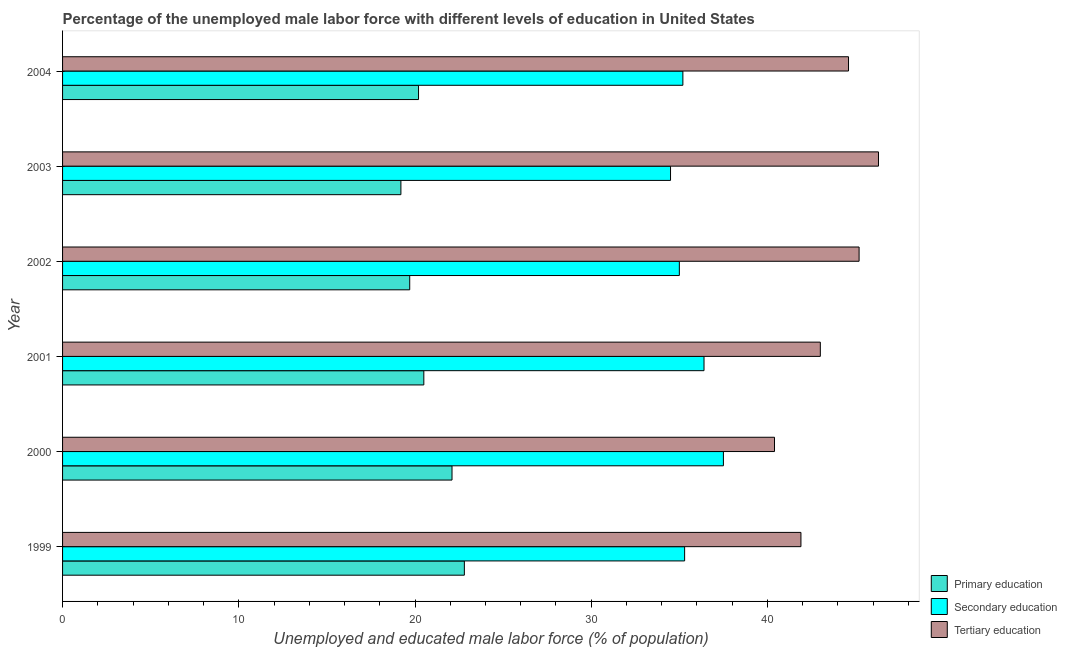How many different coloured bars are there?
Keep it short and to the point. 3. How many bars are there on the 4th tick from the top?
Give a very brief answer. 3. What is the label of the 4th group of bars from the top?
Your response must be concise. 2001. In how many cases, is the number of bars for a given year not equal to the number of legend labels?
Give a very brief answer. 0. What is the percentage of male labor force who received tertiary education in 1999?
Offer a very short reply. 41.9. Across all years, what is the maximum percentage of male labor force who received secondary education?
Make the answer very short. 37.5. Across all years, what is the minimum percentage of male labor force who received tertiary education?
Your answer should be compact. 40.4. In which year was the percentage of male labor force who received secondary education maximum?
Ensure brevity in your answer.  2000. What is the total percentage of male labor force who received primary education in the graph?
Give a very brief answer. 124.5. What is the difference between the percentage of male labor force who received tertiary education in 1999 and that in 2000?
Your answer should be compact. 1.5. What is the difference between the percentage of male labor force who received secondary education in 1999 and the percentage of male labor force who received tertiary education in 2004?
Offer a very short reply. -9.3. What is the average percentage of male labor force who received secondary education per year?
Provide a succinct answer. 35.65. In how many years, is the percentage of male labor force who received primary education greater than 18 %?
Your answer should be very brief. 6. What is the ratio of the percentage of male labor force who received secondary education in 1999 to that in 2000?
Your answer should be very brief. 0.94. Is the percentage of male labor force who received secondary education in 1999 less than that in 2000?
Your response must be concise. Yes. What is the difference between the highest and the second highest percentage of male labor force who received tertiary education?
Make the answer very short. 1.1. What is the difference between the highest and the lowest percentage of male labor force who received primary education?
Offer a terse response. 3.6. In how many years, is the percentage of male labor force who received secondary education greater than the average percentage of male labor force who received secondary education taken over all years?
Keep it short and to the point. 2. What does the 2nd bar from the bottom in 2001 represents?
Your answer should be very brief. Secondary education. How many bars are there?
Provide a succinct answer. 18. Are all the bars in the graph horizontal?
Give a very brief answer. Yes. How many years are there in the graph?
Make the answer very short. 6. What is the difference between two consecutive major ticks on the X-axis?
Your answer should be compact. 10. Does the graph contain any zero values?
Offer a very short reply. No. Does the graph contain grids?
Provide a succinct answer. No. What is the title of the graph?
Provide a succinct answer. Percentage of the unemployed male labor force with different levels of education in United States. Does "Non-communicable diseases" appear as one of the legend labels in the graph?
Provide a succinct answer. No. What is the label or title of the X-axis?
Your answer should be compact. Unemployed and educated male labor force (% of population). What is the label or title of the Y-axis?
Keep it short and to the point. Year. What is the Unemployed and educated male labor force (% of population) in Primary education in 1999?
Offer a very short reply. 22.8. What is the Unemployed and educated male labor force (% of population) of Secondary education in 1999?
Keep it short and to the point. 35.3. What is the Unemployed and educated male labor force (% of population) in Tertiary education in 1999?
Your answer should be very brief. 41.9. What is the Unemployed and educated male labor force (% of population) in Primary education in 2000?
Your response must be concise. 22.1. What is the Unemployed and educated male labor force (% of population) of Secondary education in 2000?
Your answer should be compact. 37.5. What is the Unemployed and educated male labor force (% of population) in Tertiary education in 2000?
Give a very brief answer. 40.4. What is the Unemployed and educated male labor force (% of population) in Secondary education in 2001?
Your answer should be compact. 36.4. What is the Unemployed and educated male labor force (% of population) in Primary education in 2002?
Your response must be concise. 19.7. What is the Unemployed and educated male labor force (% of population) of Secondary education in 2002?
Make the answer very short. 35. What is the Unemployed and educated male labor force (% of population) in Tertiary education in 2002?
Give a very brief answer. 45.2. What is the Unemployed and educated male labor force (% of population) of Primary education in 2003?
Your answer should be very brief. 19.2. What is the Unemployed and educated male labor force (% of population) in Secondary education in 2003?
Keep it short and to the point. 34.5. What is the Unemployed and educated male labor force (% of population) in Tertiary education in 2003?
Keep it short and to the point. 46.3. What is the Unemployed and educated male labor force (% of population) of Primary education in 2004?
Provide a succinct answer. 20.2. What is the Unemployed and educated male labor force (% of population) of Secondary education in 2004?
Your response must be concise. 35.2. What is the Unemployed and educated male labor force (% of population) in Tertiary education in 2004?
Offer a very short reply. 44.6. Across all years, what is the maximum Unemployed and educated male labor force (% of population) in Primary education?
Ensure brevity in your answer.  22.8. Across all years, what is the maximum Unemployed and educated male labor force (% of population) in Secondary education?
Ensure brevity in your answer.  37.5. Across all years, what is the maximum Unemployed and educated male labor force (% of population) of Tertiary education?
Your answer should be very brief. 46.3. Across all years, what is the minimum Unemployed and educated male labor force (% of population) in Primary education?
Provide a short and direct response. 19.2. Across all years, what is the minimum Unemployed and educated male labor force (% of population) in Secondary education?
Ensure brevity in your answer.  34.5. Across all years, what is the minimum Unemployed and educated male labor force (% of population) in Tertiary education?
Offer a terse response. 40.4. What is the total Unemployed and educated male labor force (% of population) of Primary education in the graph?
Provide a short and direct response. 124.5. What is the total Unemployed and educated male labor force (% of population) of Secondary education in the graph?
Ensure brevity in your answer.  213.9. What is the total Unemployed and educated male labor force (% of population) in Tertiary education in the graph?
Offer a terse response. 261.4. What is the difference between the Unemployed and educated male labor force (% of population) in Secondary education in 1999 and that in 2000?
Your answer should be compact. -2.2. What is the difference between the Unemployed and educated male labor force (% of population) in Tertiary education in 1999 and that in 2000?
Keep it short and to the point. 1.5. What is the difference between the Unemployed and educated male labor force (% of population) of Primary education in 1999 and that in 2001?
Your answer should be compact. 2.3. What is the difference between the Unemployed and educated male labor force (% of population) of Secondary education in 1999 and that in 2001?
Offer a very short reply. -1.1. What is the difference between the Unemployed and educated male labor force (% of population) of Secondary education in 1999 and that in 2002?
Your answer should be compact. 0.3. What is the difference between the Unemployed and educated male labor force (% of population) of Secondary education in 1999 and that in 2003?
Make the answer very short. 0.8. What is the difference between the Unemployed and educated male labor force (% of population) in Primary education in 1999 and that in 2004?
Make the answer very short. 2.6. What is the difference between the Unemployed and educated male labor force (% of population) of Secondary education in 1999 and that in 2004?
Give a very brief answer. 0.1. What is the difference between the Unemployed and educated male labor force (% of population) of Secondary education in 2000 and that in 2001?
Offer a very short reply. 1.1. What is the difference between the Unemployed and educated male labor force (% of population) of Secondary education in 2000 and that in 2002?
Offer a very short reply. 2.5. What is the difference between the Unemployed and educated male labor force (% of population) of Tertiary education in 2000 and that in 2002?
Provide a succinct answer. -4.8. What is the difference between the Unemployed and educated male labor force (% of population) in Primary education in 2000 and that in 2003?
Keep it short and to the point. 2.9. What is the difference between the Unemployed and educated male labor force (% of population) in Secondary education in 2000 and that in 2003?
Your response must be concise. 3. What is the difference between the Unemployed and educated male labor force (% of population) of Primary education in 2000 and that in 2004?
Your answer should be compact. 1.9. What is the difference between the Unemployed and educated male labor force (% of population) in Tertiary education in 2000 and that in 2004?
Keep it short and to the point. -4.2. What is the difference between the Unemployed and educated male labor force (% of population) in Primary education in 2001 and that in 2002?
Provide a succinct answer. 0.8. What is the difference between the Unemployed and educated male labor force (% of population) of Tertiary education in 2001 and that in 2002?
Provide a short and direct response. -2.2. What is the difference between the Unemployed and educated male labor force (% of population) in Secondary education in 2001 and that in 2003?
Ensure brevity in your answer.  1.9. What is the difference between the Unemployed and educated male labor force (% of population) of Tertiary education in 2001 and that in 2003?
Provide a short and direct response. -3.3. What is the difference between the Unemployed and educated male labor force (% of population) of Primary education in 2001 and that in 2004?
Your answer should be very brief. 0.3. What is the difference between the Unemployed and educated male labor force (% of population) in Secondary education in 2001 and that in 2004?
Ensure brevity in your answer.  1.2. What is the difference between the Unemployed and educated male labor force (% of population) of Primary education in 2002 and that in 2003?
Make the answer very short. 0.5. What is the difference between the Unemployed and educated male labor force (% of population) in Tertiary education in 2002 and that in 2003?
Your response must be concise. -1.1. What is the difference between the Unemployed and educated male labor force (% of population) of Secondary education in 2002 and that in 2004?
Ensure brevity in your answer.  -0.2. What is the difference between the Unemployed and educated male labor force (% of population) of Tertiary education in 2002 and that in 2004?
Your response must be concise. 0.6. What is the difference between the Unemployed and educated male labor force (% of population) of Primary education in 2003 and that in 2004?
Offer a terse response. -1. What is the difference between the Unemployed and educated male labor force (% of population) of Secondary education in 2003 and that in 2004?
Your response must be concise. -0.7. What is the difference between the Unemployed and educated male labor force (% of population) in Tertiary education in 2003 and that in 2004?
Give a very brief answer. 1.7. What is the difference between the Unemployed and educated male labor force (% of population) in Primary education in 1999 and the Unemployed and educated male labor force (% of population) in Secondary education in 2000?
Your response must be concise. -14.7. What is the difference between the Unemployed and educated male labor force (% of population) in Primary education in 1999 and the Unemployed and educated male labor force (% of population) in Tertiary education in 2000?
Your answer should be compact. -17.6. What is the difference between the Unemployed and educated male labor force (% of population) in Primary education in 1999 and the Unemployed and educated male labor force (% of population) in Secondary education in 2001?
Your answer should be compact. -13.6. What is the difference between the Unemployed and educated male labor force (% of population) in Primary education in 1999 and the Unemployed and educated male labor force (% of population) in Tertiary education in 2001?
Your answer should be compact. -20.2. What is the difference between the Unemployed and educated male labor force (% of population) in Primary education in 1999 and the Unemployed and educated male labor force (% of population) in Secondary education in 2002?
Provide a succinct answer. -12.2. What is the difference between the Unemployed and educated male labor force (% of population) of Primary education in 1999 and the Unemployed and educated male labor force (% of population) of Tertiary education in 2002?
Your answer should be very brief. -22.4. What is the difference between the Unemployed and educated male labor force (% of population) in Secondary education in 1999 and the Unemployed and educated male labor force (% of population) in Tertiary education in 2002?
Your answer should be very brief. -9.9. What is the difference between the Unemployed and educated male labor force (% of population) in Primary education in 1999 and the Unemployed and educated male labor force (% of population) in Tertiary education in 2003?
Offer a terse response. -23.5. What is the difference between the Unemployed and educated male labor force (% of population) in Primary education in 1999 and the Unemployed and educated male labor force (% of population) in Secondary education in 2004?
Make the answer very short. -12.4. What is the difference between the Unemployed and educated male labor force (% of population) in Primary education in 1999 and the Unemployed and educated male labor force (% of population) in Tertiary education in 2004?
Make the answer very short. -21.8. What is the difference between the Unemployed and educated male labor force (% of population) in Primary education in 2000 and the Unemployed and educated male labor force (% of population) in Secondary education in 2001?
Provide a succinct answer. -14.3. What is the difference between the Unemployed and educated male labor force (% of population) in Primary education in 2000 and the Unemployed and educated male labor force (% of population) in Tertiary education in 2001?
Your answer should be compact. -20.9. What is the difference between the Unemployed and educated male labor force (% of population) of Primary education in 2000 and the Unemployed and educated male labor force (% of population) of Tertiary education in 2002?
Provide a short and direct response. -23.1. What is the difference between the Unemployed and educated male labor force (% of population) of Secondary education in 2000 and the Unemployed and educated male labor force (% of population) of Tertiary education in 2002?
Give a very brief answer. -7.7. What is the difference between the Unemployed and educated male labor force (% of population) in Primary education in 2000 and the Unemployed and educated male labor force (% of population) in Tertiary education in 2003?
Your answer should be compact. -24.2. What is the difference between the Unemployed and educated male labor force (% of population) of Secondary education in 2000 and the Unemployed and educated male labor force (% of population) of Tertiary education in 2003?
Your answer should be very brief. -8.8. What is the difference between the Unemployed and educated male labor force (% of population) of Primary education in 2000 and the Unemployed and educated male labor force (% of population) of Secondary education in 2004?
Make the answer very short. -13.1. What is the difference between the Unemployed and educated male labor force (% of population) of Primary education in 2000 and the Unemployed and educated male labor force (% of population) of Tertiary education in 2004?
Make the answer very short. -22.5. What is the difference between the Unemployed and educated male labor force (% of population) of Primary education in 2001 and the Unemployed and educated male labor force (% of population) of Tertiary education in 2002?
Keep it short and to the point. -24.7. What is the difference between the Unemployed and educated male labor force (% of population) in Secondary education in 2001 and the Unemployed and educated male labor force (% of population) in Tertiary education in 2002?
Make the answer very short. -8.8. What is the difference between the Unemployed and educated male labor force (% of population) of Primary education in 2001 and the Unemployed and educated male labor force (% of population) of Secondary education in 2003?
Give a very brief answer. -14. What is the difference between the Unemployed and educated male labor force (% of population) of Primary education in 2001 and the Unemployed and educated male labor force (% of population) of Tertiary education in 2003?
Keep it short and to the point. -25.8. What is the difference between the Unemployed and educated male labor force (% of population) of Secondary education in 2001 and the Unemployed and educated male labor force (% of population) of Tertiary education in 2003?
Provide a short and direct response. -9.9. What is the difference between the Unemployed and educated male labor force (% of population) of Primary education in 2001 and the Unemployed and educated male labor force (% of population) of Secondary education in 2004?
Make the answer very short. -14.7. What is the difference between the Unemployed and educated male labor force (% of population) in Primary education in 2001 and the Unemployed and educated male labor force (% of population) in Tertiary education in 2004?
Offer a very short reply. -24.1. What is the difference between the Unemployed and educated male labor force (% of population) of Secondary education in 2001 and the Unemployed and educated male labor force (% of population) of Tertiary education in 2004?
Provide a succinct answer. -8.2. What is the difference between the Unemployed and educated male labor force (% of population) of Primary education in 2002 and the Unemployed and educated male labor force (% of population) of Secondary education in 2003?
Provide a short and direct response. -14.8. What is the difference between the Unemployed and educated male labor force (% of population) of Primary education in 2002 and the Unemployed and educated male labor force (% of population) of Tertiary education in 2003?
Make the answer very short. -26.6. What is the difference between the Unemployed and educated male labor force (% of population) of Primary education in 2002 and the Unemployed and educated male labor force (% of population) of Secondary education in 2004?
Your response must be concise. -15.5. What is the difference between the Unemployed and educated male labor force (% of population) of Primary education in 2002 and the Unemployed and educated male labor force (% of population) of Tertiary education in 2004?
Ensure brevity in your answer.  -24.9. What is the difference between the Unemployed and educated male labor force (% of population) of Primary education in 2003 and the Unemployed and educated male labor force (% of population) of Tertiary education in 2004?
Your answer should be compact. -25.4. What is the difference between the Unemployed and educated male labor force (% of population) of Secondary education in 2003 and the Unemployed and educated male labor force (% of population) of Tertiary education in 2004?
Your answer should be very brief. -10.1. What is the average Unemployed and educated male labor force (% of population) in Primary education per year?
Your response must be concise. 20.75. What is the average Unemployed and educated male labor force (% of population) of Secondary education per year?
Offer a terse response. 35.65. What is the average Unemployed and educated male labor force (% of population) of Tertiary education per year?
Offer a terse response. 43.57. In the year 1999, what is the difference between the Unemployed and educated male labor force (% of population) in Primary education and Unemployed and educated male labor force (% of population) in Secondary education?
Keep it short and to the point. -12.5. In the year 1999, what is the difference between the Unemployed and educated male labor force (% of population) of Primary education and Unemployed and educated male labor force (% of population) of Tertiary education?
Give a very brief answer. -19.1. In the year 1999, what is the difference between the Unemployed and educated male labor force (% of population) of Secondary education and Unemployed and educated male labor force (% of population) of Tertiary education?
Your answer should be compact. -6.6. In the year 2000, what is the difference between the Unemployed and educated male labor force (% of population) in Primary education and Unemployed and educated male labor force (% of population) in Secondary education?
Keep it short and to the point. -15.4. In the year 2000, what is the difference between the Unemployed and educated male labor force (% of population) of Primary education and Unemployed and educated male labor force (% of population) of Tertiary education?
Offer a very short reply. -18.3. In the year 2000, what is the difference between the Unemployed and educated male labor force (% of population) of Secondary education and Unemployed and educated male labor force (% of population) of Tertiary education?
Keep it short and to the point. -2.9. In the year 2001, what is the difference between the Unemployed and educated male labor force (% of population) in Primary education and Unemployed and educated male labor force (% of population) in Secondary education?
Your answer should be very brief. -15.9. In the year 2001, what is the difference between the Unemployed and educated male labor force (% of population) of Primary education and Unemployed and educated male labor force (% of population) of Tertiary education?
Offer a terse response. -22.5. In the year 2001, what is the difference between the Unemployed and educated male labor force (% of population) of Secondary education and Unemployed and educated male labor force (% of population) of Tertiary education?
Offer a terse response. -6.6. In the year 2002, what is the difference between the Unemployed and educated male labor force (% of population) in Primary education and Unemployed and educated male labor force (% of population) in Secondary education?
Offer a terse response. -15.3. In the year 2002, what is the difference between the Unemployed and educated male labor force (% of population) of Primary education and Unemployed and educated male labor force (% of population) of Tertiary education?
Offer a terse response. -25.5. In the year 2003, what is the difference between the Unemployed and educated male labor force (% of population) in Primary education and Unemployed and educated male labor force (% of population) in Secondary education?
Offer a terse response. -15.3. In the year 2003, what is the difference between the Unemployed and educated male labor force (% of population) of Primary education and Unemployed and educated male labor force (% of population) of Tertiary education?
Provide a short and direct response. -27.1. In the year 2004, what is the difference between the Unemployed and educated male labor force (% of population) in Primary education and Unemployed and educated male labor force (% of population) in Tertiary education?
Keep it short and to the point. -24.4. What is the ratio of the Unemployed and educated male labor force (% of population) in Primary education in 1999 to that in 2000?
Offer a terse response. 1.03. What is the ratio of the Unemployed and educated male labor force (% of population) in Secondary education in 1999 to that in 2000?
Give a very brief answer. 0.94. What is the ratio of the Unemployed and educated male labor force (% of population) of Tertiary education in 1999 to that in 2000?
Offer a very short reply. 1.04. What is the ratio of the Unemployed and educated male labor force (% of population) of Primary education in 1999 to that in 2001?
Provide a succinct answer. 1.11. What is the ratio of the Unemployed and educated male labor force (% of population) of Secondary education in 1999 to that in 2001?
Your answer should be compact. 0.97. What is the ratio of the Unemployed and educated male labor force (% of population) of Tertiary education in 1999 to that in 2001?
Offer a terse response. 0.97. What is the ratio of the Unemployed and educated male labor force (% of population) in Primary education in 1999 to that in 2002?
Offer a terse response. 1.16. What is the ratio of the Unemployed and educated male labor force (% of population) of Secondary education in 1999 to that in 2002?
Offer a terse response. 1.01. What is the ratio of the Unemployed and educated male labor force (% of population) in Tertiary education in 1999 to that in 2002?
Your answer should be compact. 0.93. What is the ratio of the Unemployed and educated male labor force (% of population) in Primary education in 1999 to that in 2003?
Make the answer very short. 1.19. What is the ratio of the Unemployed and educated male labor force (% of population) of Secondary education in 1999 to that in 2003?
Your answer should be compact. 1.02. What is the ratio of the Unemployed and educated male labor force (% of population) in Tertiary education in 1999 to that in 2003?
Make the answer very short. 0.91. What is the ratio of the Unemployed and educated male labor force (% of population) of Primary education in 1999 to that in 2004?
Provide a succinct answer. 1.13. What is the ratio of the Unemployed and educated male labor force (% of population) of Secondary education in 1999 to that in 2004?
Your response must be concise. 1. What is the ratio of the Unemployed and educated male labor force (% of population) in Tertiary education in 1999 to that in 2004?
Make the answer very short. 0.94. What is the ratio of the Unemployed and educated male labor force (% of population) of Primary education in 2000 to that in 2001?
Keep it short and to the point. 1.08. What is the ratio of the Unemployed and educated male labor force (% of population) of Secondary education in 2000 to that in 2001?
Offer a very short reply. 1.03. What is the ratio of the Unemployed and educated male labor force (% of population) in Tertiary education in 2000 to that in 2001?
Your answer should be compact. 0.94. What is the ratio of the Unemployed and educated male labor force (% of population) of Primary education in 2000 to that in 2002?
Give a very brief answer. 1.12. What is the ratio of the Unemployed and educated male labor force (% of population) in Secondary education in 2000 to that in 2002?
Your response must be concise. 1.07. What is the ratio of the Unemployed and educated male labor force (% of population) in Tertiary education in 2000 to that in 2002?
Give a very brief answer. 0.89. What is the ratio of the Unemployed and educated male labor force (% of population) in Primary education in 2000 to that in 2003?
Provide a succinct answer. 1.15. What is the ratio of the Unemployed and educated male labor force (% of population) of Secondary education in 2000 to that in 2003?
Give a very brief answer. 1.09. What is the ratio of the Unemployed and educated male labor force (% of population) of Tertiary education in 2000 to that in 2003?
Offer a terse response. 0.87. What is the ratio of the Unemployed and educated male labor force (% of population) of Primary education in 2000 to that in 2004?
Give a very brief answer. 1.09. What is the ratio of the Unemployed and educated male labor force (% of population) of Secondary education in 2000 to that in 2004?
Ensure brevity in your answer.  1.07. What is the ratio of the Unemployed and educated male labor force (% of population) in Tertiary education in 2000 to that in 2004?
Ensure brevity in your answer.  0.91. What is the ratio of the Unemployed and educated male labor force (% of population) of Primary education in 2001 to that in 2002?
Ensure brevity in your answer.  1.04. What is the ratio of the Unemployed and educated male labor force (% of population) in Secondary education in 2001 to that in 2002?
Your answer should be compact. 1.04. What is the ratio of the Unemployed and educated male labor force (% of population) in Tertiary education in 2001 to that in 2002?
Make the answer very short. 0.95. What is the ratio of the Unemployed and educated male labor force (% of population) in Primary education in 2001 to that in 2003?
Keep it short and to the point. 1.07. What is the ratio of the Unemployed and educated male labor force (% of population) in Secondary education in 2001 to that in 2003?
Offer a very short reply. 1.06. What is the ratio of the Unemployed and educated male labor force (% of population) in Tertiary education in 2001 to that in 2003?
Provide a short and direct response. 0.93. What is the ratio of the Unemployed and educated male labor force (% of population) of Primary education in 2001 to that in 2004?
Your response must be concise. 1.01. What is the ratio of the Unemployed and educated male labor force (% of population) of Secondary education in 2001 to that in 2004?
Offer a terse response. 1.03. What is the ratio of the Unemployed and educated male labor force (% of population) of Tertiary education in 2001 to that in 2004?
Your answer should be very brief. 0.96. What is the ratio of the Unemployed and educated male labor force (% of population) of Primary education in 2002 to that in 2003?
Your response must be concise. 1.03. What is the ratio of the Unemployed and educated male labor force (% of population) of Secondary education in 2002 to that in 2003?
Your answer should be very brief. 1.01. What is the ratio of the Unemployed and educated male labor force (% of population) of Tertiary education in 2002 to that in 2003?
Your answer should be compact. 0.98. What is the ratio of the Unemployed and educated male labor force (% of population) in Primary education in 2002 to that in 2004?
Provide a short and direct response. 0.98. What is the ratio of the Unemployed and educated male labor force (% of population) in Tertiary education in 2002 to that in 2004?
Your answer should be compact. 1.01. What is the ratio of the Unemployed and educated male labor force (% of population) in Primary education in 2003 to that in 2004?
Provide a short and direct response. 0.95. What is the ratio of the Unemployed and educated male labor force (% of population) of Secondary education in 2003 to that in 2004?
Give a very brief answer. 0.98. What is the ratio of the Unemployed and educated male labor force (% of population) of Tertiary education in 2003 to that in 2004?
Give a very brief answer. 1.04. What is the difference between the highest and the second highest Unemployed and educated male labor force (% of population) of Primary education?
Keep it short and to the point. 0.7. What is the difference between the highest and the second highest Unemployed and educated male labor force (% of population) in Tertiary education?
Make the answer very short. 1.1. What is the difference between the highest and the lowest Unemployed and educated male labor force (% of population) of Primary education?
Your answer should be very brief. 3.6. What is the difference between the highest and the lowest Unemployed and educated male labor force (% of population) in Secondary education?
Keep it short and to the point. 3. What is the difference between the highest and the lowest Unemployed and educated male labor force (% of population) of Tertiary education?
Your answer should be very brief. 5.9. 